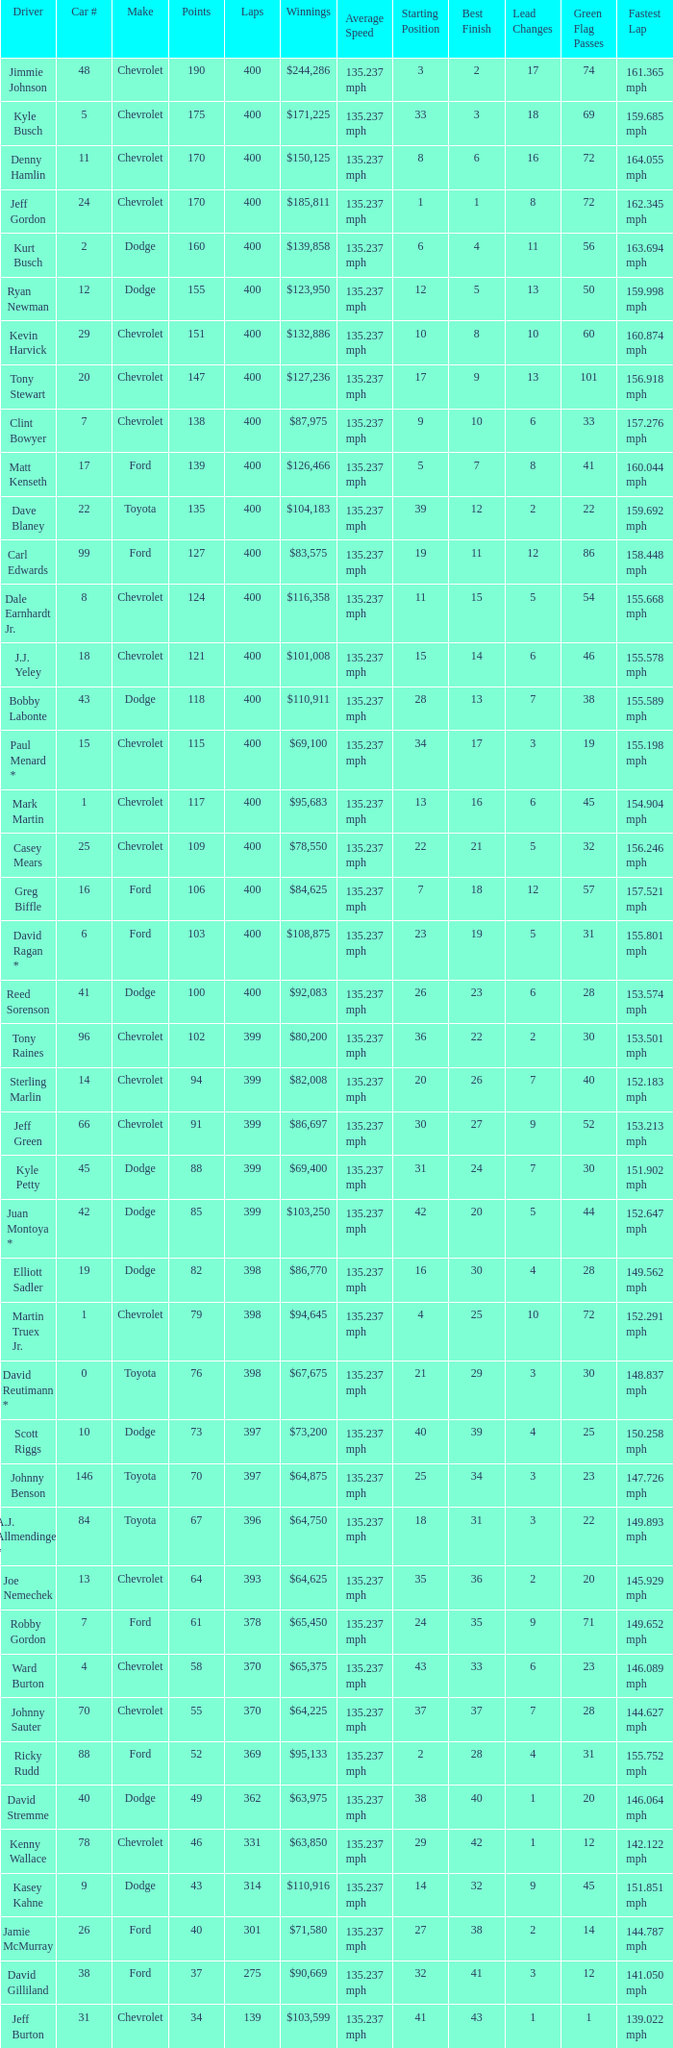Could you parse the entire table as a dict? {'header': ['Driver', 'Car #', 'Make', 'Points', 'Laps', 'Winnings', 'Average Speed', 'Starting Position', 'Best Finish', 'Lead Changes', 'Green Flag Passes', 'Fastest Lap'], 'rows': [['Jimmie Johnson', '48', 'Chevrolet', '190', '400', '$244,286', '135.237 mph', '3', '2', '17', '74', '161.365 mph'], ['Kyle Busch', '5', 'Chevrolet', '175', '400', '$171,225', '135.237 mph', '33', '3', '18', '69', '159.685 mph'], ['Denny Hamlin', '11', 'Chevrolet', '170', '400', '$150,125', '135.237 mph', '8', '6', '16', '72', '164.055 mph'], ['Jeff Gordon', '24', 'Chevrolet', '170', '400', '$185,811', '135.237 mph', '1', '1', '8', '72', '162.345 mph'], ['Kurt Busch', '2', 'Dodge', '160', '400', '$139,858', '135.237 mph', '6', '4', '11', '56', '163.694 mph'], ['Ryan Newman', '12', 'Dodge', '155', '400', '$123,950', '135.237 mph', '12', '5', '13', '50', '159.998 mph'], ['Kevin Harvick', '29', 'Chevrolet', '151', '400', '$132,886', '135.237 mph', '10', '8', '10', '60', '160.874 mph'], ['Tony Stewart', '20', 'Chevrolet', '147', '400', '$127,236', '135.237 mph', '17', '9', '13', '101', '156.918 mph'], ['Clint Bowyer', '7', 'Chevrolet', '138', '400', '$87,975', '135.237 mph', '9', '10', '6', '33', '157.276 mph'], ['Matt Kenseth', '17', 'Ford', '139', '400', '$126,466', '135.237 mph', '5', '7', '8', '41', '160.044 mph'], ['Dave Blaney', '22', 'Toyota', '135', '400', '$104,183', '135.237 mph', '39', '12', '2', '22', '159.692 mph'], ['Carl Edwards', '99', 'Ford', '127', '400', '$83,575', '135.237 mph', '19', '11', '12', '86', '158.448 mph'], ['Dale Earnhardt Jr.', '8', 'Chevrolet', '124', '400', '$116,358', '135.237 mph', '11', '15', '5', '54', '155.668 mph'], ['J.J. Yeley', '18', 'Chevrolet', '121', '400', '$101,008', '135.237 mph', '15', '14', '6', '46', '155.578 mph'], ['Bobby Labonte', '43', 'Dodge', '118', '400', '$110,911', '135.237 mph', '28', '13', '7', '38', '155.589 mph'], ['Paul Menard *', '15', 'Chevrolet', '115', '400', '$69,100', '135.237 mph', '34', '17', '3', '19', '155.198 mph'], ['Mark Martin', '1', 'Chevrolet', '117', '400', '$95,683', '135.237 mph', '13', '16', '6', '45', '154.904 mph'], ['Casey Mears', '25', 'Chevrolet', '109', '400', '$78,550', '135.237 mph', '22', '21', '5', '32', '156.246 mph'], ['Greg Biffle', '16', 'Ford', '106', '400', '$84,625', '135.237 mph', '7', '18', '12', '57', '157.521 mph'], ['David Ragan *', '6', 'Ford', '103', '400', '$108,875', '135.237 mph', '23', '19', '5', '31', '155.801 mph'], ['Reed Sorenson', '41', 'Dodge', '100', '400', '$92,083', '135.237 mph', '26', '23', '6', '28', '153.574 mph'], ['Tony Raines', '96', 'Chevrolet', '102', '399', '$80,200', '135.237 mph', '36', '22', '2', '30', '153.501 mph'], ['Sterling Marlin', '14', 'Chevrolet', '94', '399', '$82,008', '135.237 mph', '20', '26', '7', '40', '152.183 mph'], ['Jeff Green', '66', 'Chevrolet', '91', '399', '$86,697', '135.237 mph', '30', '27', '9', '52', '153.213 mph'], ['Kyle Petty', '45', 'Dodge', '88', '399', '$69,400', '135.237 mph', '31', '24', '7', '30', '151.902 mph'], ['Juan Montoya *', '42', 'Dodge', '85', '399', '$103,250', '135.237 mph', '42', '20', '5', '44', '152.647 mph'], ['Elliott Sadler', '19', 'Dodge', '82', '398', '$86,770', '135.237 mph', '16', '30', '4', '28', '149.562 mph'], ['Martin Truex Jr.', '1', 'Chevrolet', '79', '398', '$94,645', '135.237 mph', '4', '25', '10', '72', '152.291 mph'], ['David Reutimann *', '0', 'Toyota', '76', '398', '$67,675', '135.237 mph', '21', '29', '3', '30', '148.837 mph'], ['Scott Riggs', '10', 'Dodge', '73', '397', '$73,200', '135.237 mph', '40', '39', '4', '25', '150.258 mph'], ['Johnny Benson', '146', 'Toyota', '70', '397', '$64,875', '135.237 mph', '25', '34', '3', '23', '147.726 mph'], ['A.J. Allmendinger *', '84', 'Toyota', '67', '396', '$64,750', '135.237 mph', '18', '31', '3', '22', '149.893 mph'], ['Joe Nemechek', '13', 'Chevrolet', '64', '393', '$64,625', '135.237 mph', '35', '36', '2', '20', '145.929 mph'], ['Robby Gordon', '7', 'Ford', '61', '378', '$65,450', '135.237 mph', '24', '35', '9', '71', '149.652 mph'], ['Ward Burton', '4', 'Chevrolet', '58', '370', '$65,375', '135.237 mph', '43', '33', '6', '23', '146.089 mph'], ['Johnny Sauter', '70', 'Chevrolet', '55', '370', '$64,225', '135.237 mph', '37', '37', '7', '28', '144.627 mph'], ['Ricky Rudd', '88', 'Ford', '52', '369', '$95,133', '135.237 mph', '2', '28', '4', '31', '155.752 mph'], ['David Stremme', '40', 'Dodge', '49', '362', '$63,975', '135.237 mph', '38', '40', '1', '20', '146.064 mph'], ['Kenny Wallace', '78', 'Chevrolet', '46', '331', '$63,850', '135.237 mph', '29', '42', '1', '12', '142.122 mph'], ['Kasey Kahne', '9', 'Dodge', '43', '314', '$110,916', '135.237 mph', '14', '32', '9', '45', '151.851 mph'], ['Jamie McMurray', '26', 'Ford', '40', '301', '$71,580', '135.237 mph', '27', '38', '2', '14', '144.787 mph'], ['David Gilliland', '38', 'Ford', '37', '275', '$90,669', '135.237 mph', '32', '41', '3', '12', '141.050 mph'], ['Jeff Burton', '31', 'Chevrolet', '34', '139', '$103,599', '135.237 mph', '41', '43', '1', '1', '139.022 mph']]} What is the make of car 31? Chevrolet. 